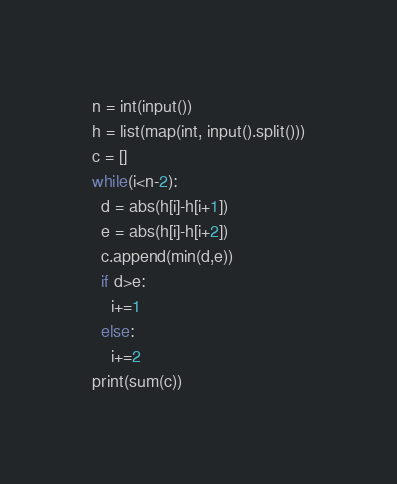<code> <loc_0><loc_0><loc_500><loc_500><_Python_>n = int(input())
h = list(map(int, input().split()))
c = []
while(i<n-2):
  d = abs(h[i]-h[i+1])
  e = abs(h[i]-h[i+2])
  c.append(min(d,e))
  if d>e:
  	i+=1
  else:
    i+=2
print(sum(c))</code> 